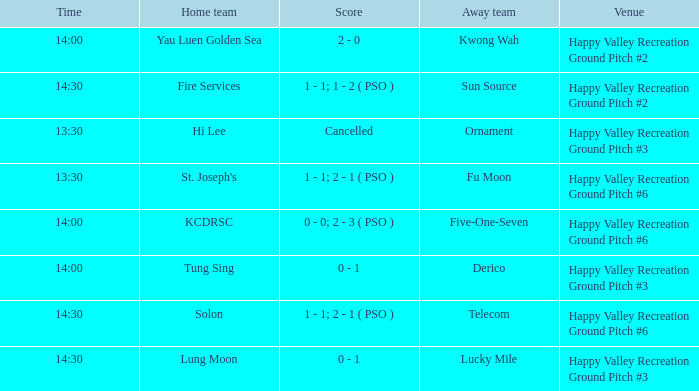What is the venue of the match with a 14:30 time and sun source as the away team? Happy Valley Recreation Ground Pitch #2. 